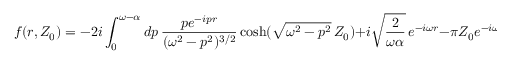Convert formula to latex. <formula><loc_0><loc_0><loc_500><loc_500>f ( r , Z _ { 0 } ) = - 2 i \int _ { 0 } ^ { \omega - \alpha } d p \, \frac { p e ^ { - i p r } } { ( \omega ^ { 2 } - p ^ { 2 } ) ^ { 3 / 2 } } \cosh ( \sqrt { \omega ^ { 2 } - p ^ { 2 } } \, Z _ { 0 } ) + i \sqrt { \frac { 2 } { \omega \alpha } } \, e ^ { - i \omega r } - \pi Z _ { 0 } e ^ { - i \omega r } .</formula> 